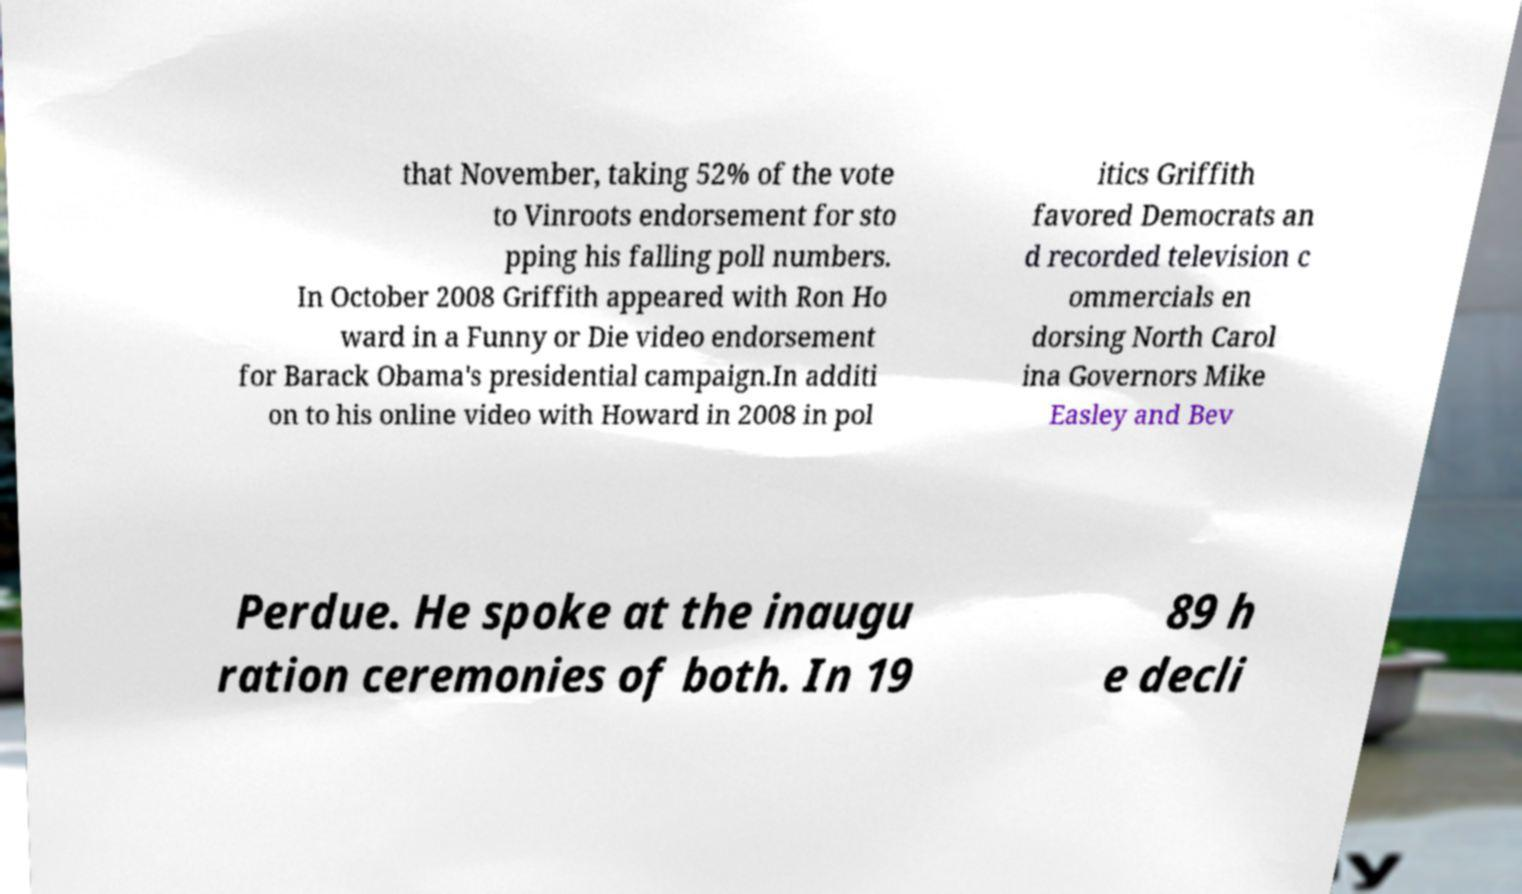Can you read and provide the text displayed in the image?This photo seems to have some interesting text. Can you extract and type it out for me? that November, taking 52% of the vote to Vinroots endorsement for sto pping his falling poll numbers. In October 2008 Griffith appeared with Ron Ho ward in a Funny or Die video endorsement for Barack Obama's presidential campaign.In additi on to his online video with Howard in 2008 in pol itics Griffith favored Democrats an d recorded television c ommercials en dorsing North Carol ina Governors Mike Easley and Bev Perdue. He spoke at the inaugu ration ceremonies of both. In 19 89 h e decli 